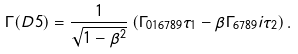<formula> <loc_0><loc_0><loc_500><loc_500>\Gamma ( D 5 ) = \frac { 1 } { \sqrt { 1 - \beta ^ { 2 } } } \left ( \Gamma _ { 0 1 6 7 8 9 } \tau _ { 1 } - \beta \Gamma _ { 6 7 8 9 } i \tau _ { 2 } \right ) .</formula> 